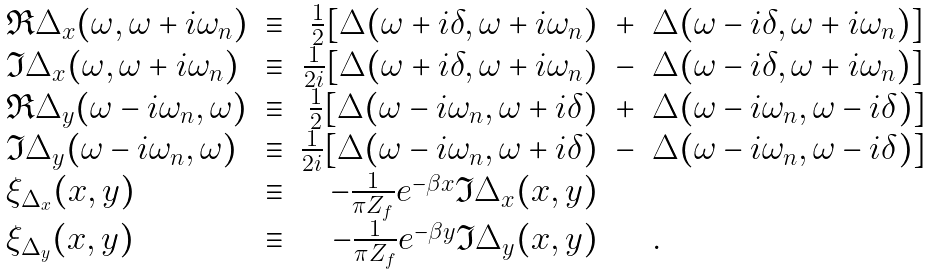Convert formula to latex. <formula><loc_0><loc_0><loc_500><loc_500>\begin{array} { l c r c l } \Re \Delta _ { x } ( \omega , \omega + i \omega _ { n } ) & \equiv & \frac { 1 } { 2 } [ \Delta ( \omega + i \delta , \omega + i \omega _ { n } ) & + & \Delta ( \omega - i \delta , \omega + i \omega _ { n } ) ] \\ \Im \Delta _ { x } ( \omega , \omega + i \omega _ { n } ) & \equiv & \frac { 1 } { 2 i } [ \Delta ( \omega + i \delta , \omega + i \omega _ { n } ) & - & \Delta ( \omega - i \delta , \omega + i \omega _ { n } ) ] \\ \Re \Delta _ { y } ( \omega - i \omega _ { n } , \omega ) & \equiv & \frac { 1 } { 2 } [ \Delta ( \omega - i \omega _ { n } , \omega + i \delta ) & + & \Delta ( \omega - i \omega _ { n } , \omega - i \delta ) ] \\ \Im \Delta _ { y } ( \omega - i \omega _ { n } , \omega ) & \equiv & \frac { 1 } { 2 i } [ \Delta ( \omega - i \omega _ { n } , \omega + i \delta ) & - & \Delta ( \omega - i \omega _ { n } , \omega - i \delta ) ] \\ \xi _ { \Delta _ { x } } ( x , y ) & \equiv & - \frac { 1 } { \pi Z _ { f } } e ^ { - \beta x } \Im \Delta _ { x } ( x , y ) & & \\ \xi _ { \Delta _ { y } } ( x , y ) & \equiv & - \frac { 1 } { \pi Z _ { f } } e ^ { - \beta y } \Im \Delta _ { y } ( x , y ) & & . \end{array}</formula> 